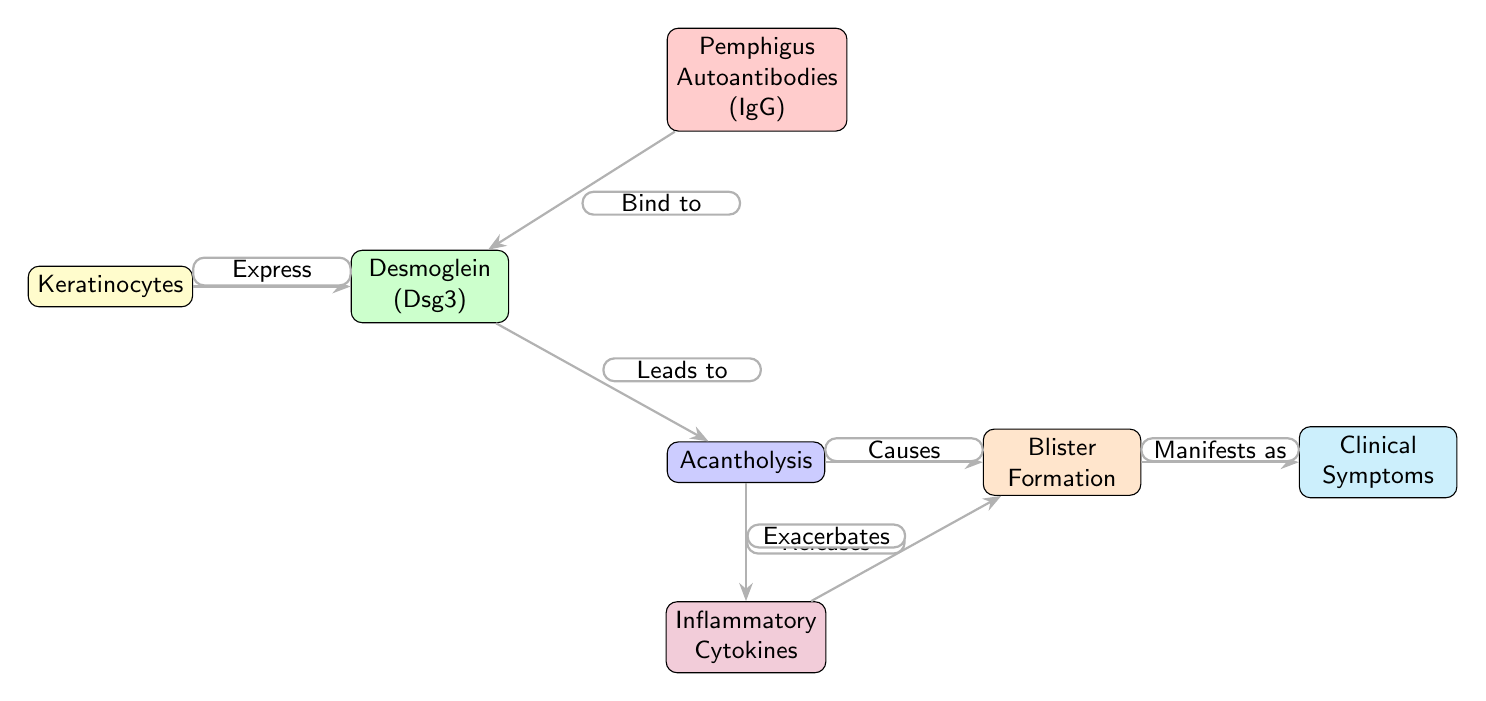What is the first node in the diagram? The first node is located at the leftmost position and represents the initial component of the flow, which is "Keratinocytes."
Answer: Keratinocytes What are the two main processes that occur after acantholysis? After acantholysis, two main processes occur: it leads to blister formation and releases inflammatory cytokines. This can be determined by examining the arrows leading out from the acantholysis node.
Answer: Blister Formation and Inflammatory Cytokines How many arrows are in the diagram? By counting the arrows connecting the nodes, we can see there are six distinct arrows indicating the flow of information and relationships in the diagram.
Answer: 6 What does pemphigus autoantibodies bind to? The diagram shows that pemphigus autoantibodies bind to desmoglein, as indicated by the labeled arrow pointing from pemphigus to desmoglein.
Answer: Desmoglein What symptoms result from the interaction of blister formation and cytokines? The diagram shows that both blister formation and inflammatory cytokines contribute to "Clinical Symptoms," as represented by the arrows pointing to this node at the rightmost end of the flow.
Answer: Clinical Symptoms What triggers acantholysis in the diagram? Acantholysis is triggered by the binding of pemphigus autoantibodies to desmoglein, as illustrated by the arrow leading from desmoglein to acantholysis.
Answer: Binding of pemphigus autoantibodies What does acantholysis cause? According to the diagram, acantholysis causes blister formation as indicated by the labeled arrow connecting these two nodes.
Answer: Blister Formation What type of immune component is represented by the pemphigus node? The pemphigus node represents an immune component characterized as autoantibodies, specifically IgG. This is evident from the label within the node itself.
Answer: Autoantibodies (IgG) 